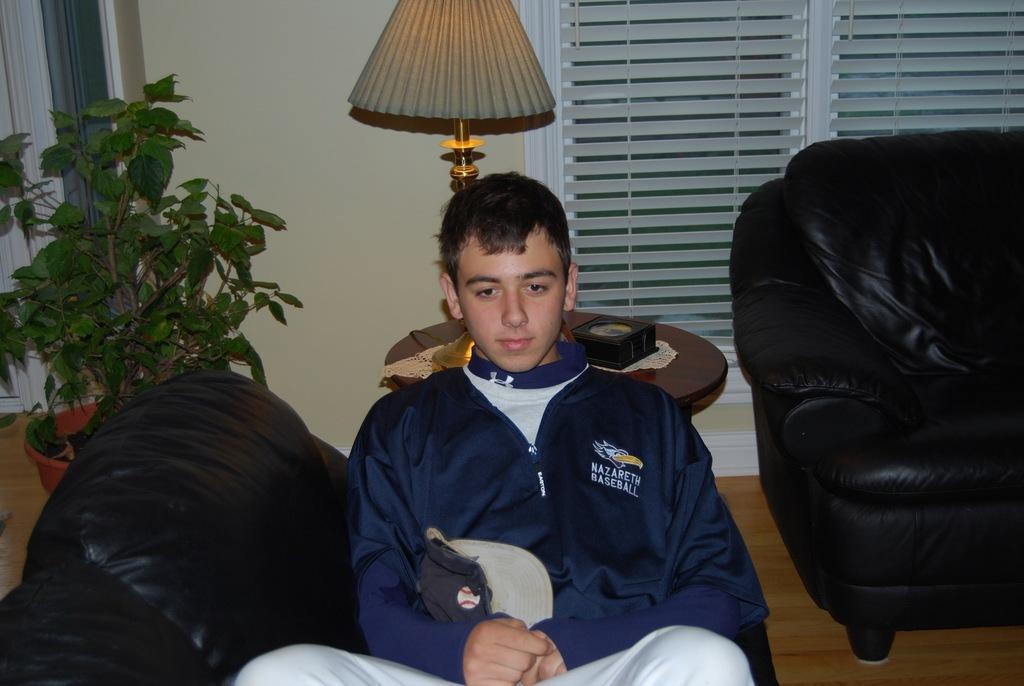Could you give a brief overview of what you see in this image? This picture shows a man seated on the chair and we see a plant and a lamp on the table and we see blinds to the window and a sofa on the side 